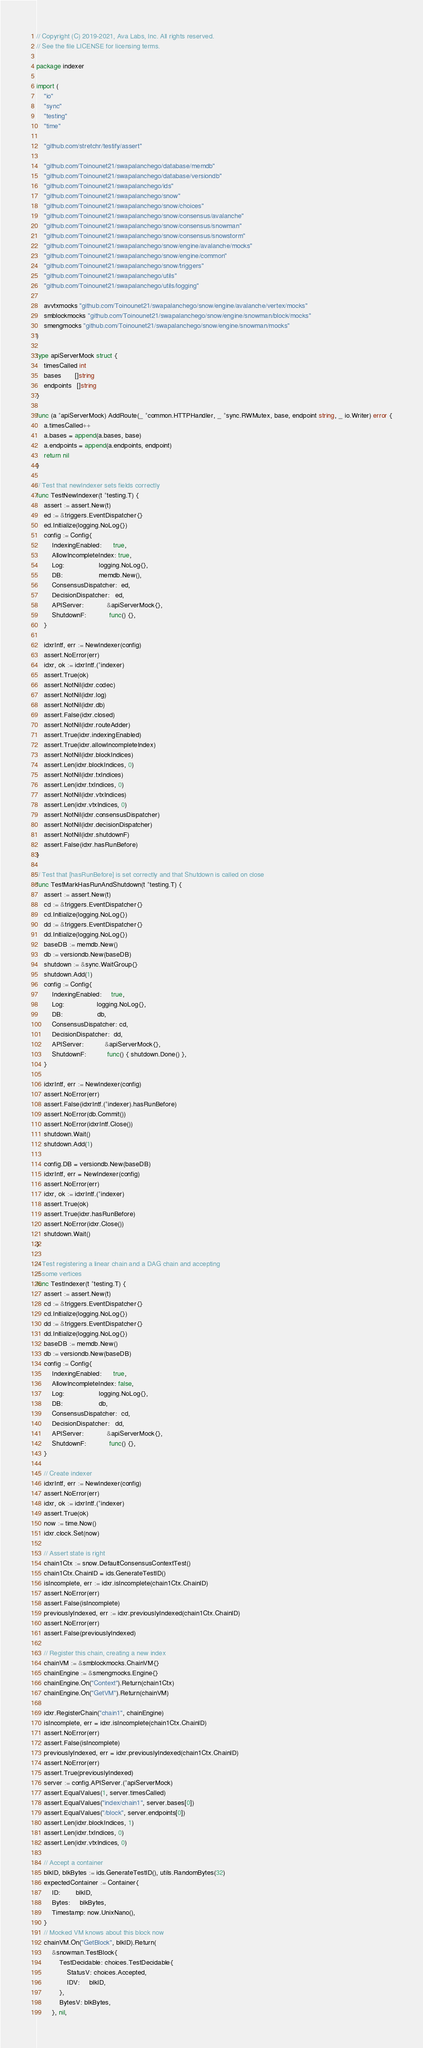<code> <loc_0><loc_0><loc_500><loc_500><_Go_>// Copyright (C) 2019-2021, Ava Labs, Inc. All rights reserved.
// See the file LICENSE for licensing terms.

package indexer

import (
	"io"
	"sync"
	"testing"
	"time"

	"github.com/stretchr/testify/assert"

	"github.com/Toinounet21/swapalanchego/database/memdb"
	"github.com/Toinounet21/swapalanchego/database/versiondb"
	"github.com/Toinounet21/swapalanchego/ids"
	"github.com/Toinounet21/swapalanchego/snow"
	"github.com/Toinounet21/swapalanchego/snow/choices"
	"github.com/Toinounet21/swapalanchego/snow/consensus/avalanche"
	"github.com/Toinounet21/swapalanchego/snow/consensus/snowman"
	"github.com/Toinounet21/swapalanchego/snow/consensus/snowstorm"
	"github.com/Toinounet21/swapalanchego/snow/engine/avalanche/mocks"
	"github.com/Toinounet21/swapalanchego/snow/engine/common"
	"github.com/Toinounet21/swapalanchego/snow/triggers"
	"github.com/Toinounet21/swapalanchego/utils"
	"github.com/Toinounet21/swapalanchego/utils/logging"

	avvtxmocks "github.com/Toinounet21/swapalanchego/snow/engine/avalanche/vertex/mocks"
	smblockmocks "github.com/Toinounet21/swapalanchego/snow/engine/snowman/block/mocks"
	smengmocks "github.com/Toinounet21/swapalanchego/snow/engine/snowman/mocks"
)

type apiServerMock struct {
	timesCalled int
	bases       []string
	endpoints   []string
}

func (a *apiServerMock) AddRoute(_ *common.HTTPHandler, _ *sync.RWMutex, base, endpoint string, _ io.Writer) error {
	a.timesCalled++
	a.bases = append(a.bases, base)
	a.endpoints = append(a.endpoints, endpoint)
	return nil
}

// Test that newIndexer sets fields correctly
func TestNewIndexer(t *testing.T) {
	assert := assert.New(t)
	ed := &triggers.EventDispatcher{}
	ed.Initialize(logging.NoLog{})
	config := Config{
		IndexingEnabled:      true,
		AllowIncompleteIndex: true,
		Log:                  logging.NoLog{},
		DB:                   memdb.New(),
		ConsensusDispatcher:  ed,
		DecisionDispatcher:   ed,
		APIServer:            &apiServerMock{},
		ShutdownF:            func() {},
	}

	idxrIntf, err := NewIndexer(config)
	assert.NoError(err)
	idxr, ok := idxrIntf.(*indexer)
	assert.True(ok)
	assert.NotNil(idxr.codec)
	assert.NotNil(idxr.log)
	assert.NotNil(idxr.db)
	assert.False(idxr.closed)
	assert.NotNil(idxr.routeAdder)
	assert.True(idxr.indexingEnabled)
	assert.True(idxr.allowIncompleteIndex)
	assert.NotNil(idxr.blockIndices)
	assert.Len(idxr.blockIndices, 0)
	assert.NotNil(idxr.txIndices)
	assert.Len(idxr.txIndices, 0)
	assert.NotNil(idxr.vtxIndices)
	assert.Len(idxr.vtxIndices, 0)
	assert.NotNil(idxr.consensusDispatcher)
	assert.NotNil(idxr.decisionDispatcher)
	assert.NotNil(idxr.shutdownF)
	assert.False(idxr.hasRunBefore)
}

// Test that [hasRunBefore] is set correctly and that Shutdown is called on close
func TestMarkHasRunAndShutdown(t *testing.T) {
	assert := assert.New(t)
	cd := &triggers.EventDispatcher{}
	cd.Initialize(logging.NoLog{})
	dd := &triggers.EventDispatcher{}
	dd.Initialize(logging.NoLog{})
	baseDB := memdb.New()
	db := versiondb.New(baseDB)
	shutdown := &sync.WaitGroup{}
	shutdown.Add(1)
	config := Config{
		IndexingEnabled:     true,
		Log:                 logging.NoLog{},
		DB:                  db,
		ConsensusDispatcher: cd,
		DecisionDispatcher:  dd,
		APIServer:           &apiServerMock{},
		ShutdownF:           func() { shutdown.Done() },
	}

	idxrIntf, err := NewIndexer(config)
	assert.NoError(err)
	assert.False(idxrIntf.(*indexer).hasRunBefore)
	assert.NoError(db.Commit())
	assert.NoError(idxrIntf.Close())
	shutdown.Wait()
	shutdown.Add(1)

	config.DB = versiondb.New(baseDB)
	idxrIntf, err = NewIndexer(config)
	assert.NoError(err)
	idxr, ok := idxrIntf.(*indexer)
	assert.True(ok)
	assert.True(idxr.hasRunBefore)
	assert.NoError(idxr.Close())
	shutdown.Wait()
}

// Test registering a linear chain and a DAG chain and accepting
// some vertices
func TestIndexer(t *testing.T) {
	assert := assert.New(t)
	cd := &triggers.EventDispatcher{}
	cd.Initialize(logging.NoLog{})
	dd := &triggers.EventDispatcher{}
	dd.Initialize(logging.NoLog{})
	baseDB := memdb.New()
	db := versiondb.New(baseDB)
	config := Config{
		IndexingEnabled:      true,
		AllowIncompleteIndex: false,
		Log:                  logging.NoLog{},
		DB:                   db,
		ConsensusDispatcher:  cd,
		DecisionDispatcher:   dd,
		APIServer:            &apiServerMock{},
		ShutdownF:            func() {},
	}

	// Create indexer
	idxrIntf, err := NewIndexer(config)
	assert.NoError(err)
	idxr, ok := idxrIntf.(*indexer)
	assert.True(ok)
	now := time.Now()
	idxr.clock.Set(now)

	// Assert state is right
	chain1Ctx := snow.DefaultConsensusContextTest()
	chain1Ctx.ChainID = ids.GenerateTestID()
	isIncomplete, err := idxr.isIncomplete(chain1Ctx.ChainID)
	assert.NoError(err)
	assert.False(isIncomplete)
	previouslyIndexed, err := idxr.previouslyIndexed(chain1Ctx.ChainID)
	assert.NoError(err)
	assert.False(previouslyIndexed)

	// Register this chain, creating a new index
	chainVM := &smblockmocks.ChainVM{}
	chainEngine := &smengmocks.Engine{}
	chainEngine.On("Context").Return(chain1Ctx)
	chainEngine.On("GetVM").Return(chainVM)

	idxr.RegisterChain("chain1", chainEngine)
	isIncomplete, err = idxr.isIncomplete(chain1Ctx.ChainID)
	assert.NoError(err)
	assert.False(isIncomplete)
	previouslyIndexed, err = idxr.previouslyIndexed(chain1Ctx.ChainID)
	assert.NoError(err)
	assert.True(previouslyIndexed)
	server := config.APIServer.(*apiServerMock)
	assert.EqualValues(1, server.timesCalled)
	assert.EqualValues("index/chain1", server.bases[0])
	assert.EqualValues("/block", server.endpoints[0])
	assert.Len(idxr.blockIndices, 1)
	assert.Len(idxr.txIndices, 0)
	assert.Len(idxr.vtxIndices, 0)

	// Accept a container
	blkID, blkBytes := ids.GenerateTestID(), utils.RandomBytes(32)
	expectedContainer := Container{
		ID:        blkID,
		Bytes:     blkBytes,
		Timestamp: now.UnixNano(),
	}
	// Mocked VM knows about this block now
	chainVM.On("GetBlock", blkID).Return(
		&snowman.TestBlock{
			TestDecidable: choices.TestDecidable{
				StatusV: choices.Accepted,
				IDV:     blkID,
			},
			BytesV: blkBytes,
		}, nil,</code> 